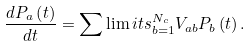<formula> <loc_0><loc_0><loc_500><loc_500>\frac { d P _ { a } \left ( t \right ) } { d t } = \sum \lim i t s _ { b = 1 } ^ { N _ { c } } V _ { a b } P _ { b } \left ( t \right ) .</formula> 